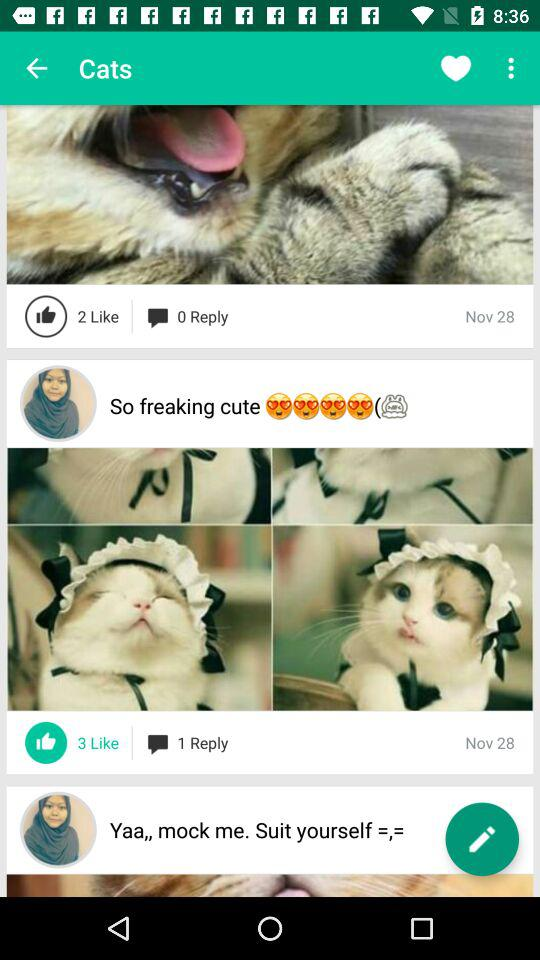How many cats are wearing a hat?
Answer the question using a single word or phrase. 2 